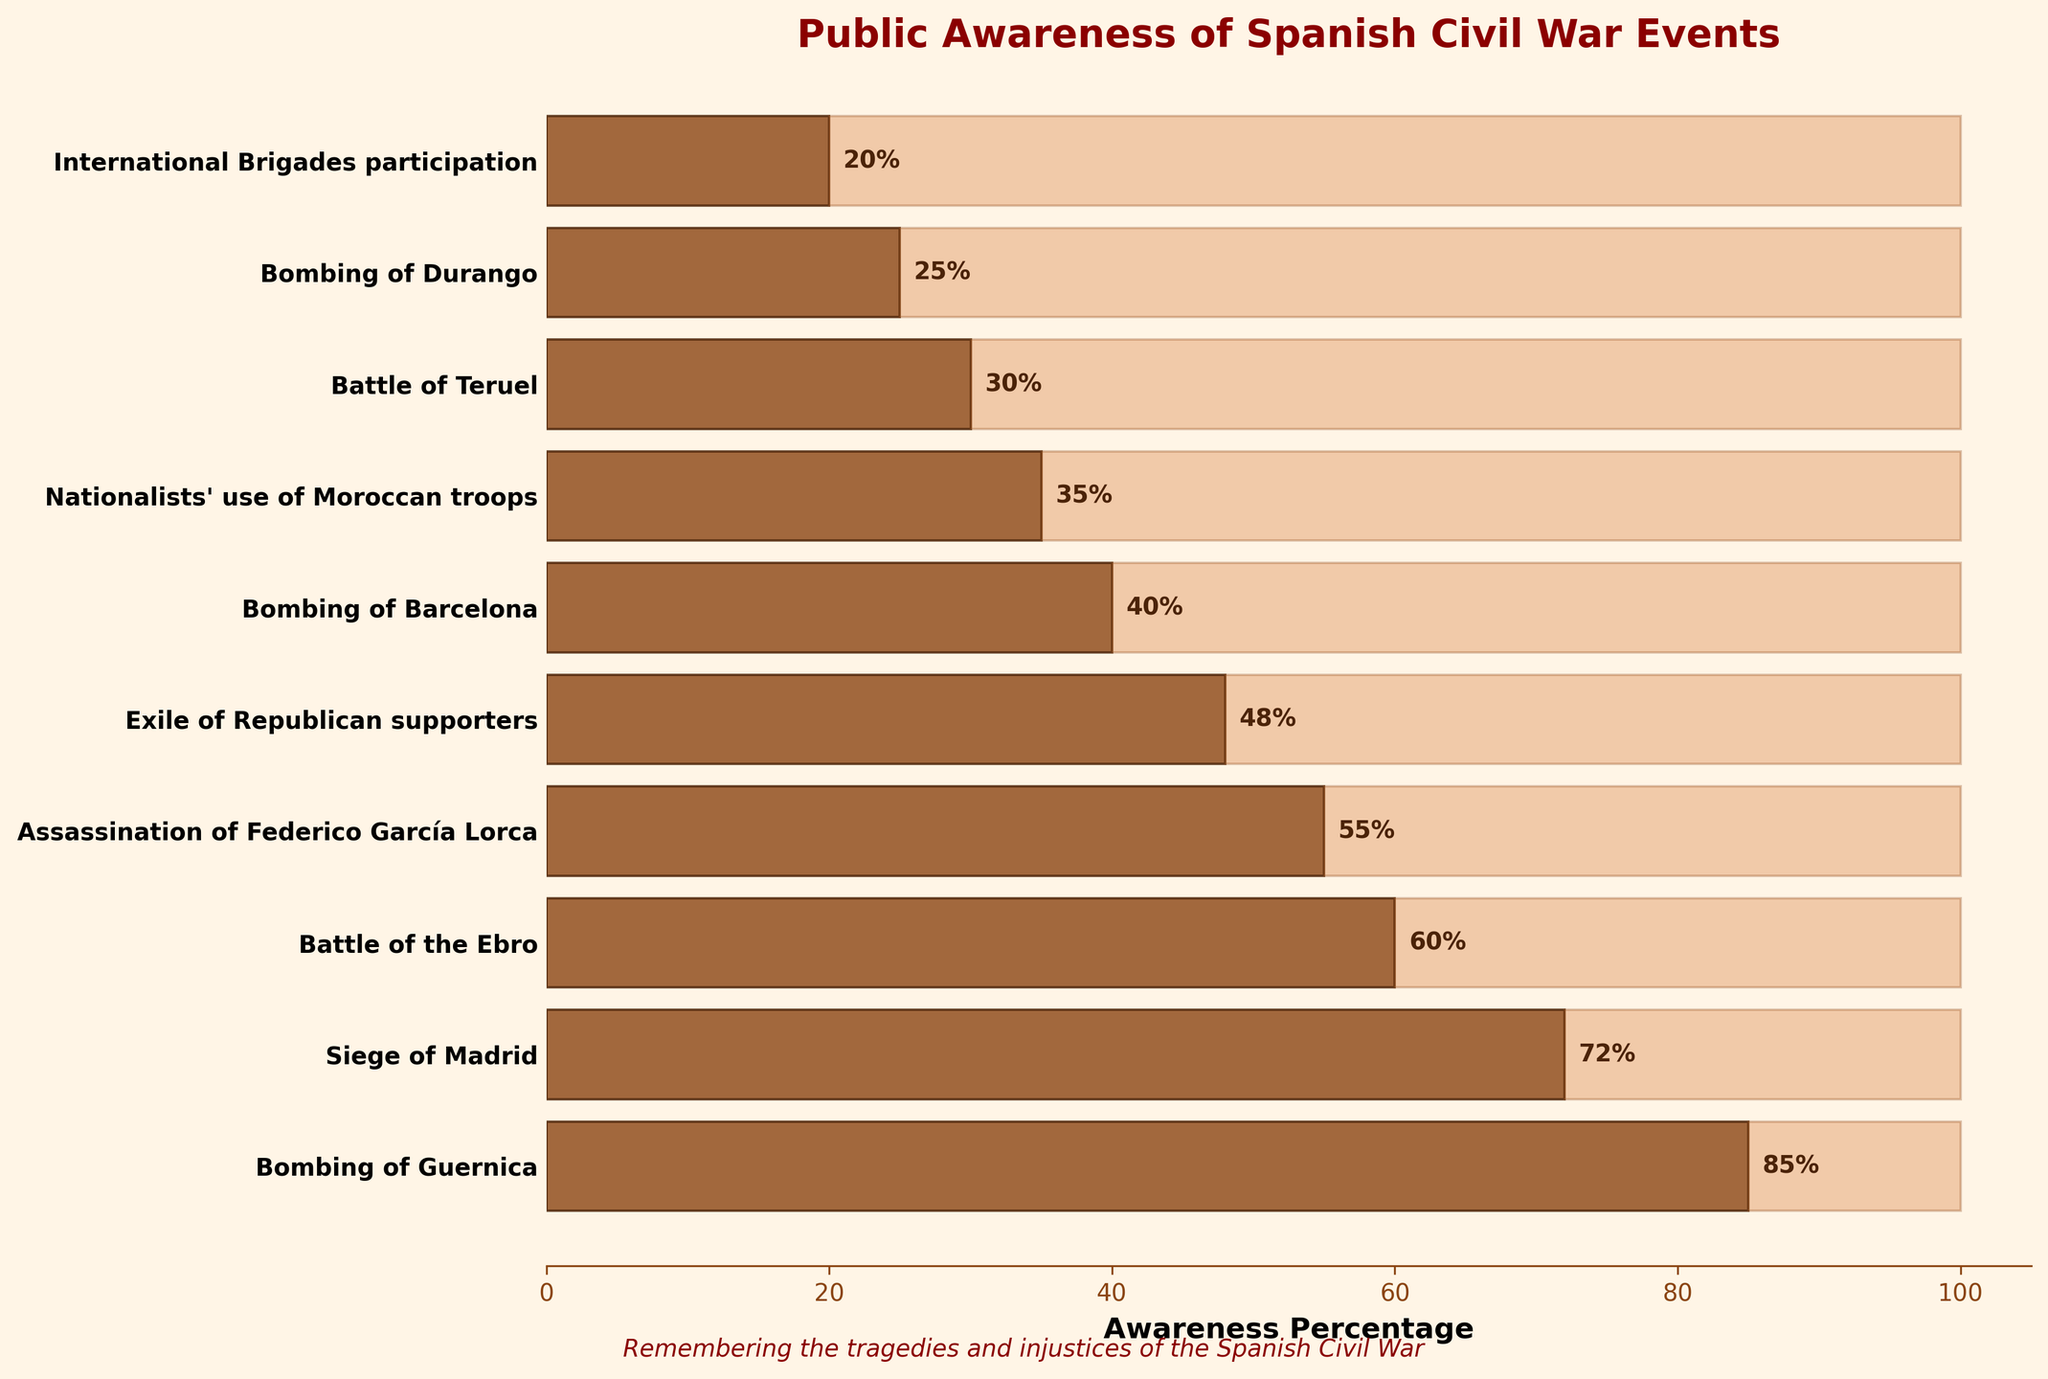What is the most known event from the Spanish Civil War according to the funnel chart? The most known event is indicated by the bar with the highest awareness percentage. According to the figure, the "Bombing of Guernica" has the highest awareness percentage of 85%.
Answer: Bombing of Guernica What is the least known event from the Spanish Civil War according to the funnel chart? The least known event is indicated by the bar with the lowest awareness percentage. According to the figure, the "International Brigades participation" has the lowest awareness percentage of 20%.
Answer: International Brigades participation How many events have an awareness percentage of 50% or more? To determine this, we need to count the number of bars with percentages of 50% or more. According to the figure, five events have awareness percentages of 50% or more (Bombing of Guernica, Siege of Madrid, Battle of the Ebro, Assassination of Federico García Lorca, and Exile of Republican supporters).
Answer: 5 How much higher is the awareness percentage of the "Battle of the Ebro" than the "Battle of Teruel"? We find the awareness percentage of both events and then calculate the difference. "Battle of the Ebro" has 60% awareness, and "Battle of Teruel" has 30% awareness, so the difference is 60% - 30% = 30%.
Answer: 30% What is the average awareness percentage of the top three most known events? Calculate the average by summing the percentages of the top three events and then dividing by three. The top three events (Bombing of Guernica, Siege of Madrid, Battle of the Ebro) have percentages of 85%, 72%, and 60%. The sum is 85 + 72 + 60 = 217. The average is 217 / 3 = 72.33.
Answer: 72.33 Which event has 55% awareness? Locate the bar with an awareness percentage of 55%. According to the figure, the "Assassination of Federico García Lorca" has a 55% awareness percentage.
Answer: Assassination of Federico García Lorca How much more aware is the public of the "Exile of Republican supporters" compared to the "Bombing of Durango"? Determine the difference in awareness percentages between the two events. "Exile of Republican supporters" has 48% awareness, and "Bombing of Durango" has 25% awareness, so the difference is 48% - 25% = 23%.
Answer: 23% List the events where public awareness is less than 50%. Identify the events with awareness percentages less than 50%. According to the figure, these events are Exile of Republican supporters, Bombing of Barcelona, Nationalists' use of Moroccan troops, Battle of Teruel, Bombing of Durango, and International Brigades participation.
Answer: Exile of Republican supporters, Bombing of Barcelona, Nationalists' use of Moroccan troops, Battle of Teruel, Bombing of Durango, International Brigades participation 